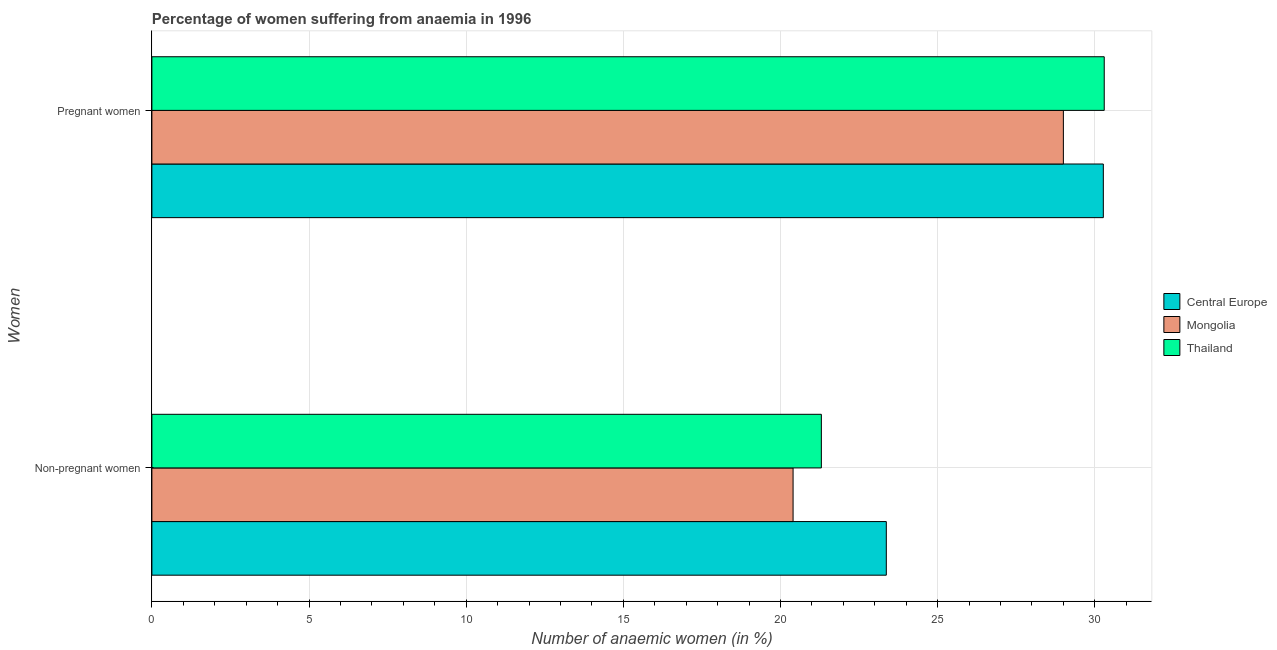How many different coloured bars are there?
Your answer should be very brief. 3. Are the number of bars per tick equal to the number of legend labels?
Provide a succinct answer. Yes. Are the number of bars on each tick of the Y-axis equal?
Keep it short and to the point. Yes. What is the label of the 2nd group of bars from the top?
Ensure brevity in your answer.  Non-pregnant women. Across all countries, what is the maximum percentage of non-pregnant anaemic women?
Your answer should be compact. 23.37. Across all countries, what is the minimum percentage of non-pregnant anaemic women?
Give a very brief answer. 20.4. In which country was the percentage of non-pregnant anaemic women maximum?
Provide a short and direct response. Central Europe. In which country was the percentage of pregnant anaemic women minimum?
Make the answer very short. Mongolia. What is the total percentage of non-pregnant anaemic women in the graph?
Your answer should be very brief. 65.07. What is the difference between the percentage of pregnant anaemic women in Thailand and that in Mongolia?
Your response must be concise. 1.3. What is the difference between the percentage of pregnant anaemic women in Thailand and the percentage of non-pregnant anaemic women in Mongolia?
Offer a very short reply. 9.9. What is the average percentage of pregnant anaemic women per country?
Your answer should be very brief. 29.86. What is the difference between the percentage of pregnant anaemic women and percentage of non-pregnant anaemic women in Thailand?
Your response must be concise. 9. What is the ratio of the percentage of pregnant anaemic women in Thailand to that in Central Europe?
Keep it short and to the point. 1. What does the 1st bar from the top in Non-pregnant women represents?
Ensure brevity in your answer.  Thailand. What does the 2nd bar from the bottom in Pregnant women represents?
Make the answer very short. Mongolia. How many bars are there?
Your response must be concise. 6. How many countries are there in the graph?
Give a very brief answer. 3. Does the graph contain any zero values?
Make the answer very short. No. Where does the legend appear in the graph?
Your response must be concise. Center right. How many legend labels are there?
Provide a short and direct response. 3. What is the title of the graph?
Give a very brief answer. Percentage of women suffering from anaemia in 1996. Does "Thailand" appear as one of the legend labels in the graph?
Provide a succinct answer. Yes. What is the label or title of the X-axis?
Offer a terse response. Number of anaemic women (in %). What is the label or title of the Y-axis?
Ensure brevity in your answer.  Women. What is the Number of anaemic women (in %) of Central Europe in Non-pregnant women?
Make the answer very short. 23.37. What is the Number of anaemic women (in %) of Mongolia in Non-pregnant women?
Offer a terse response. 20.4. What is the Number of anaemic women (in %) in Thailand in Non-pregnant women?
Provide a short and direct response. 21.3. What is the Number of anaemic women (in %) of Central Europe in Pregnant women?
Your response must be concise. 30.27. What is the Number of anaemic women (in %) in Mongolia in Pregnant women?
Make the answer very short. 29. What is the Number of anaemic women (in %) of Thailand in Pregnant women?
Provide a succinct answer. 30.3. Across all Women, what is the maximum Number of anaemic women (in %) of Central Europe?
Give a very brief answer. 30.27. Across all Women, what is the maximum Number of anaemic women (in %) in Thailand?
Your answer should be compact. 30.3. Across all Women, what is the minimum Number of anaemic women (in %) of Central Europe?
Your response must be concise. 23.37. Across all Women, what is the minimum Number of anaemic women (in %) in Mongolia?
Your response must be concise. 20.4. Across all Women, what is the minimum Number of anaemic women (in %) of Thailand?
Keep it short and to the point. 21.3. What is the total Number of anaemic women (in %) of Central Europe in the graph?
Give a very brief answer. 53.64. What is the total Number of anaemic women (in %) in Mongolia in the graph?
Your answer should be compact. 49.4. What is the total Number of anaemic women (in %) in Thailand in the graph?
Your answer should be compact. 51.6. What is the difference between the Number of anaemic women (in %) in Central Europe in Non-pregnant women and that in Pregnant women?
Your answer should be very brief. -6.9. What is the difference between the Number of anaemic women (in %) of Mongolia in Non-pregnant women and that in Pregnant women?
Provide a succinct answer. -8.6. What is the difference between the Number of anaemic women (in %) of Central Europe in Non-pregnant women and the Number of anaemic women (in %) of Mongolia in Pregnant women?
Ensure brevity in your answer.  -5.63. What is the difference between the Number of anaemic women (in %) in Central Europe in Non-pregnant women and the Number of anaemic women (in %) in Thailand in Pregnant women?
Keep it short and to the point. -6.93. What is the average Number of anaemic women (in %) of Central Europe per Women?
Your answer should be very brief. 26.82. What is the average Number of anaemic women (in %) of Mongolia per Women?
Your answer should be very brief. 24.7. What is the average Number of anaemic women (in %) of Thailand per Women?
Keep it short and to the point. 25.8. What is the difference between the Number of anaemic women (in %) of Central Europe and Number of anaemic women (in %) of Mongolia in Non-pregnant women?
Give a very brief answer. 2.97. What is the difference between the Number of anaemic women (in %) in Central Europe and Number of anaemic women (in %) in Thailand in Non-pregnant women?
Offer a very short reply. 2.07. What is the difference between the Number of anaemic women (in %) in Central Europe and Number of anaemic women (in %) in Mongolia in Pregnant women?
Your answer should be very brief. 1.27. What is the difference between the Number of anaemic women (in %) of Central Europe and Number of anaemic women (in %) of Thailand in Pregnant women?
Provide a succinct answer. -0.03. What is the ratio of the Number of anaemic women (in %) of Central Europe in Non-pregnant women to that in Pregnant women?
Keep it short and to the point. 0.77. What is the ratio of the Number of anaemic women (in %) in Mongolia in Non-pregnant women to that in Pregnant women?
Provide a succinct answer. 0.7. What is the ratio of the Number of anaemic women (in %) in Thailand in Non-pregnant women to that in Pregnant women?
Give a very brief answer. 0.7. What is the difference between the highest and the second highest Number of anaemic women (in %) in Central Europe?
Offer a very short reply. 6.9. What is the difference between the highest and the lowest Number of anaemic women (in %) of Central Europe?
Provide a succinct answer. 6.9. What is the difference between the highest and the lowest Number of anaemic women (in %) in Mongolia?
Your response must be concise. 8.6. 